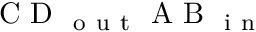<formula> <loc_0><loc_0><loc_500><loc_500>C D _ { o u t } A B _ { i n }</formula> 